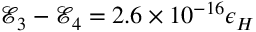<formula> <loc_0><loc_0><loc_500><loc_500>\mathcal { E } _ { 3 } - \mathcal { E } _ { 4 } = 2 . 6 \times 1 0 ^ { - 1 6 } \epsilon _ { H }</formula> 